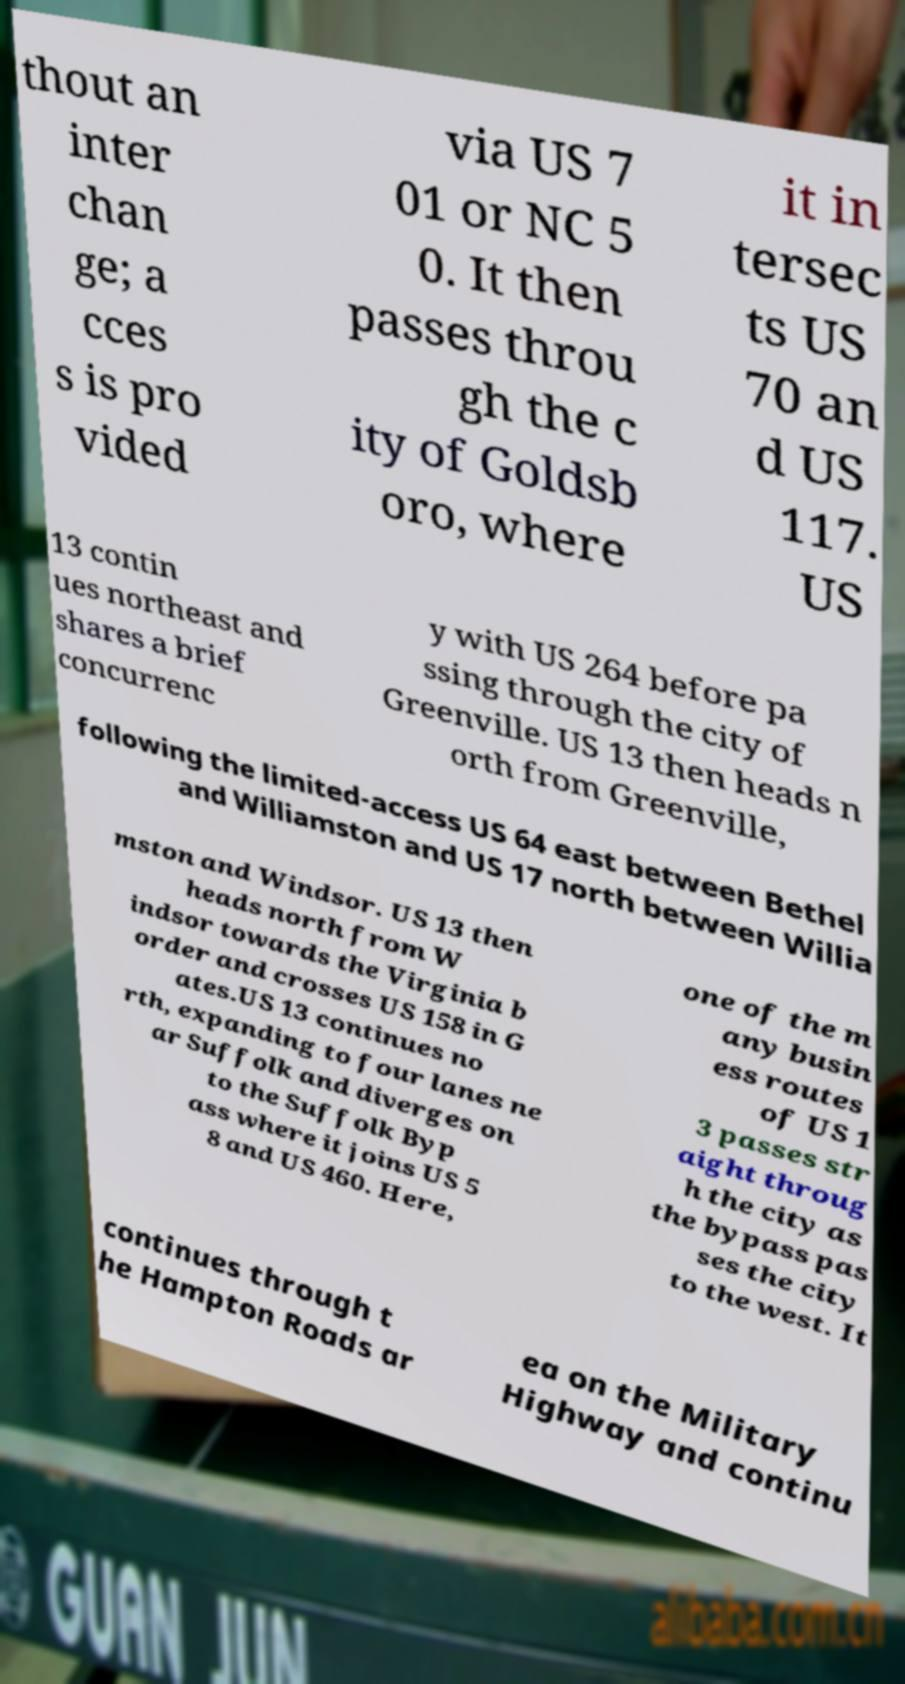Please read and relay the text visible in this image. What does it say? thout an inter chan ge; a cces s is pro vided via US 7 01 or NC 5 0. It then passes throu gh the c ity of Goldsb oro, where it in tersec ts US 70 an d US 117. US 13 contin ues northeast and shares a brief concurrenc y with US 264 before pa ssing through the city of Greenville. US 13 then heads n orth from Greenville, following the limited-access US 64 east between Bethel and Williamston and US 17 north between Willia mston and Windsor. US 13 then heads north from W indsor towards the Virginia b order and crosses US 158 in G ates.US 13 continues no rth, expanding to four lanes ne ar Suffolk and diverges on to the Suffolk Byp ass where it joins US 5 8 and US 460. Here, one of the m any busin ess routes of US 1 3 passes str aight throug h the city as the bypass pas ses the city to the west. It continues through t he Hampton Roads ar ea on the Military Highway and continu 